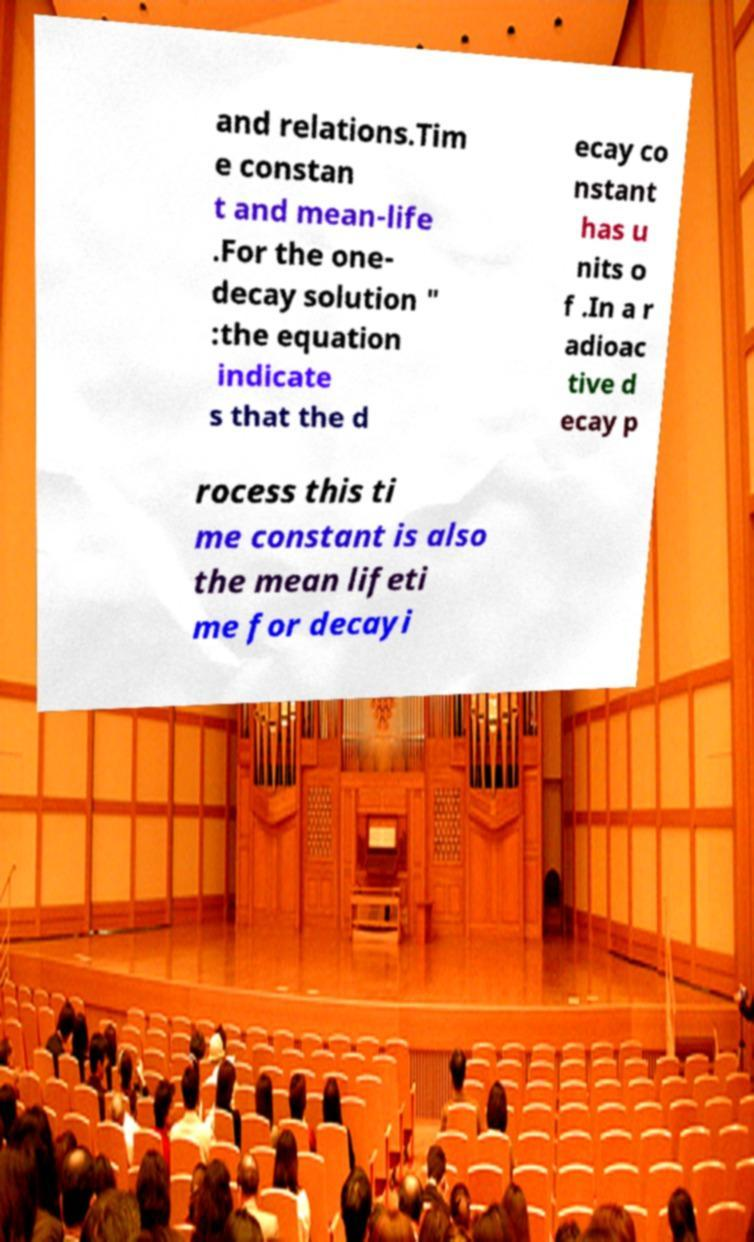Please identify and transcribe the text found in this image. and relations.Tim e constan t and mean-life .For the one- decay solution " :the equation indicate s that the d ecay co nstant has u nits o f .In a r adioac tive d ecay p rocess this ti me constant is also the mean lifeti me for decayi 